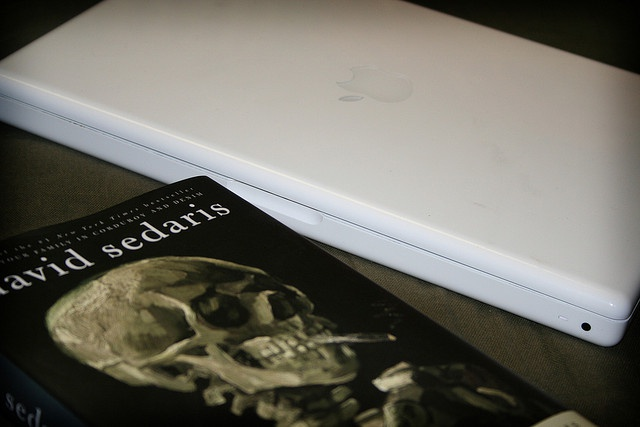Describe the objects in this image and their specific colors. I can see laptop in black, darkgray, lightgray, and gray tones and book in black, darkgreen, gray, and olive tones in this image. 